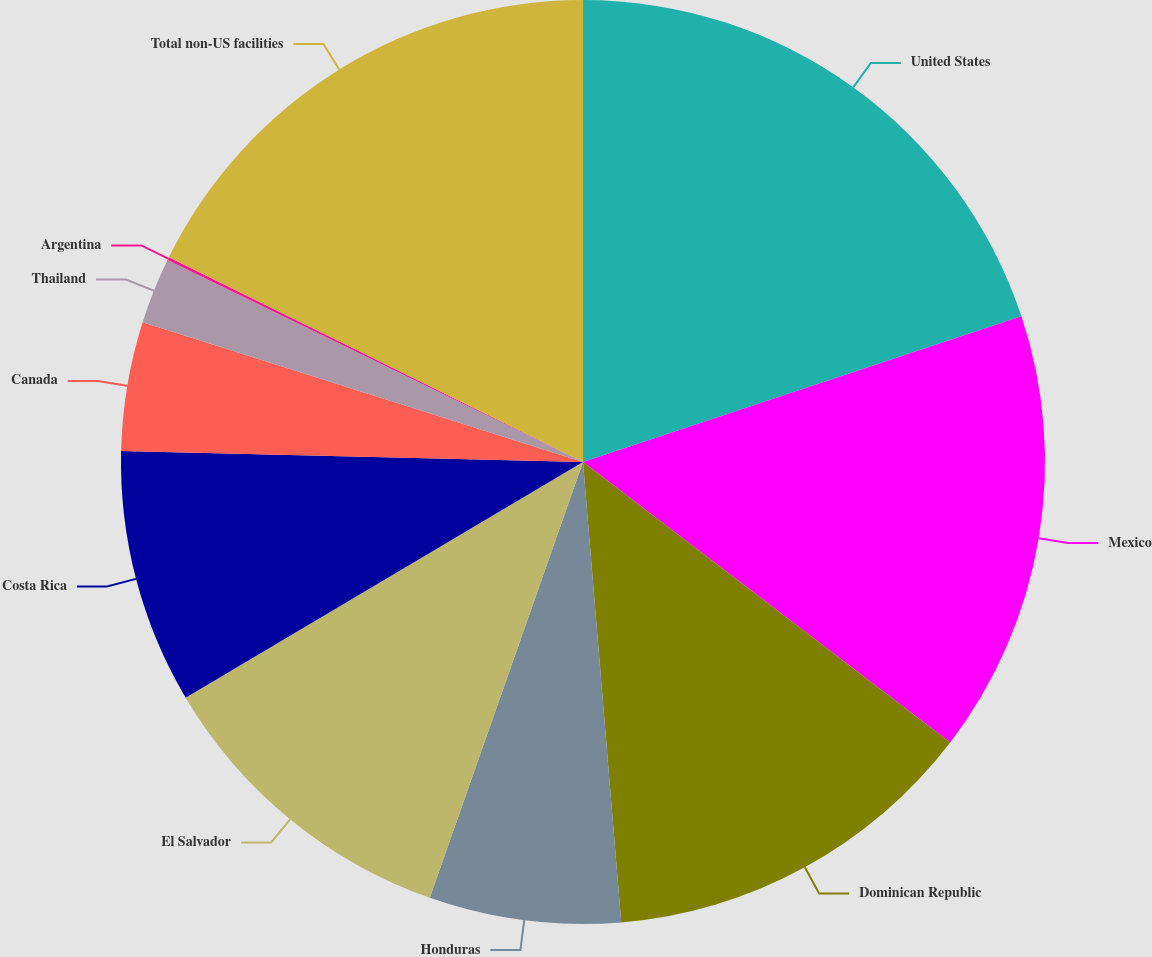<chart> <loc_0><loc_0><loc_500><loc_500><pie_chart><fcel>United States<fcel>Mexico<fcel>Dominican Republic<fcel>Honduras<fcel>El Salvador<fcel>Costa Rica<fcel>Canada<fcel>Thailand<fcel>Argentina<fcel>Total non-US facilities<nl><fcel>19.89%<fcel>15.49%<fcel>13.3%<fcel>6.7%<fcel>11.1%<fcel>8.9%<fcel>4.51%<fcel>2.31%<fcel>0.11%<fcel>17.69%<nl></chart> 